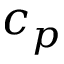Convert formula to latex. <formula><loc_0><loc_0><loc_500><loc_500>c _ { p }</formula> 